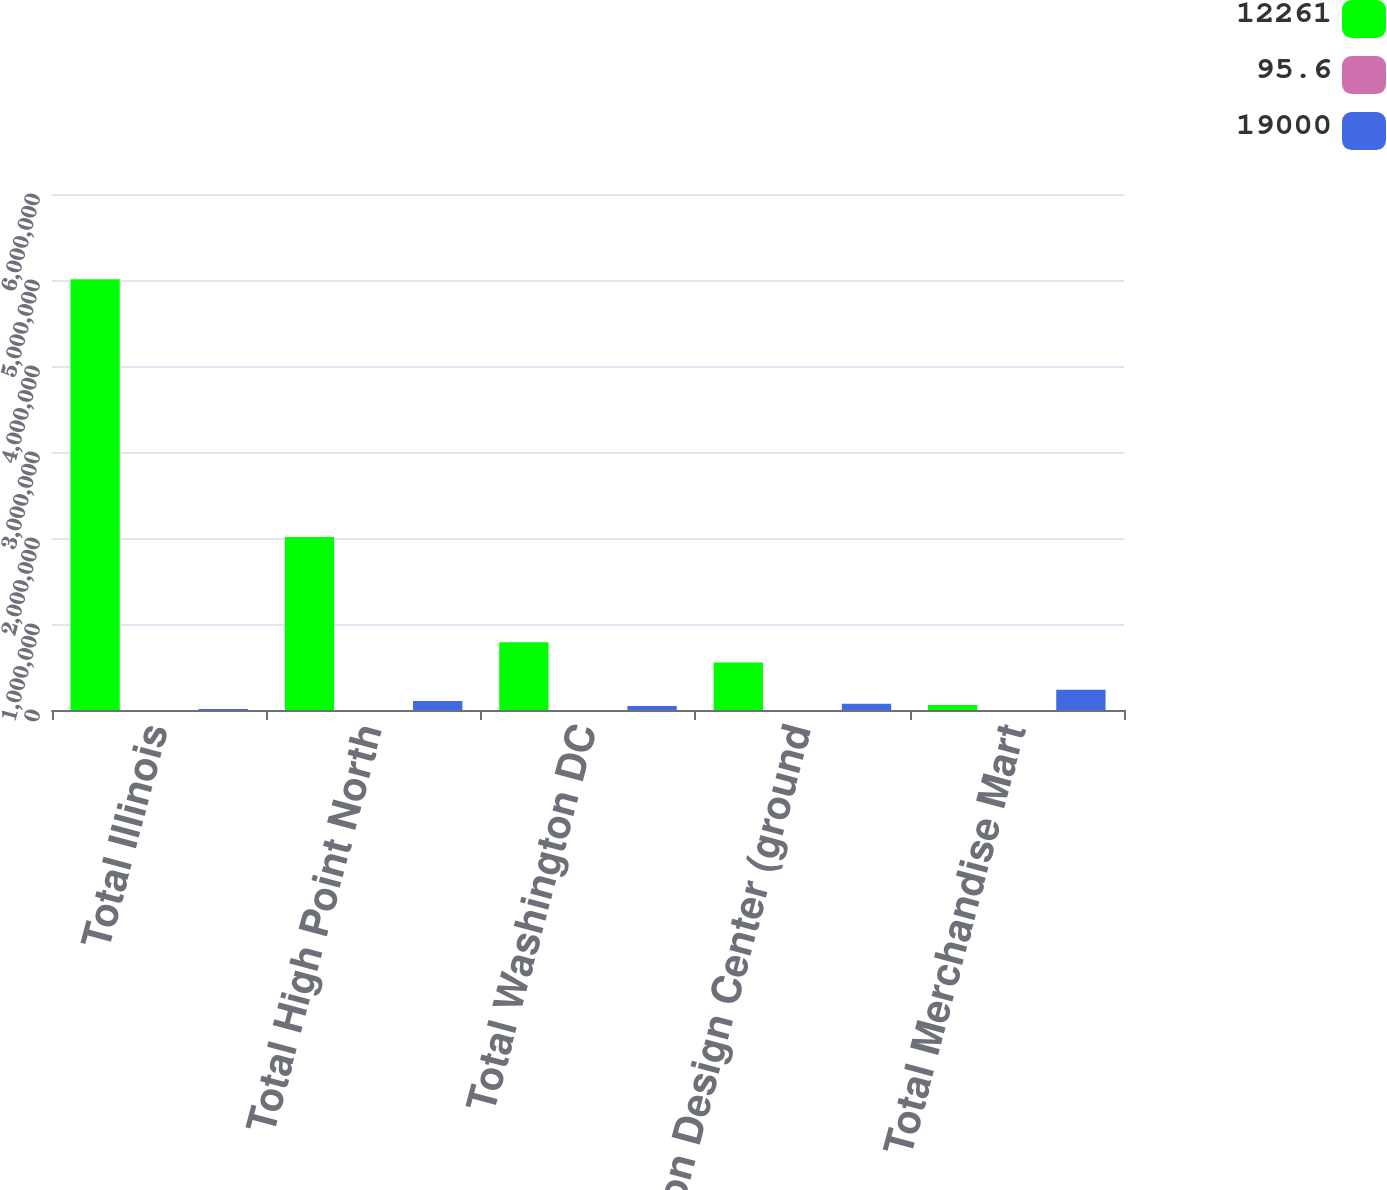<chart> <loc_0><loc_0><loc_500><loc_500><stacked_bar_chart><ecel><fcel>Total Illinois<fcel>Total High Point North<fcel>Total Washington DC<fcel>Boston Design Center (ground<fcel>Total Merchandise Mart<nl><fcel>12261<fcel>5.008e+06<fcel>2.012e+06<fcel>789000<fcel>553000<fcel>59466<nl><fcel>95.6<fcel>96.3<fcel>97.6<fcel>99.3<fcel>96.4<fcel>95.5<nl><fcel>19000<fcel>12261<fcel>104639<fcel>46932<fcel>72000<fcel>235832<nl></chart> 